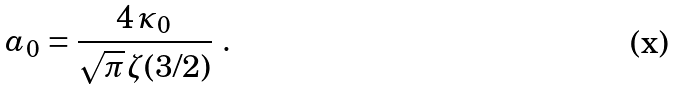<formula> <loc_0><loc_0><loc_500><loc_500>a _ { 0 } = \frac { 4 \, \kappa _ { 0 } } { \sqrt { \pi } \, \zeta ( 3 / 2 ) } \ .</formula> 